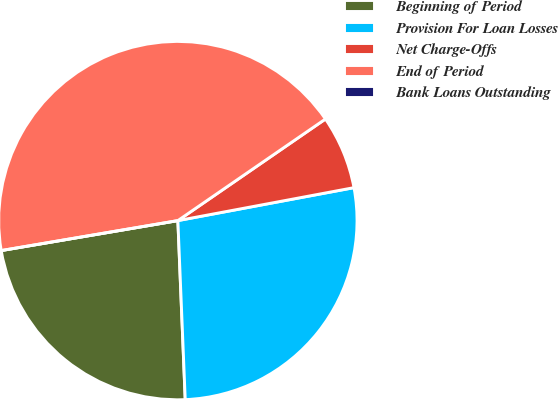Convert chart. <chart><loc_0><loc_0><loc_500><loc_500><pie_chart><fcel>Beginning of Period<fcel>Provision For Loan Losses<fcel>Net Charge-Offs<fcel>End of Period<fcel>Bank Loans Outstanding<nl><fcel>22.98%<fcel>27.29%<fcel>6.65%<fcel>43.08%<fcel>0.0%<nl></chart> 